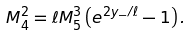Convert formula to latex. <formula><loc_0><loc_0><loc_500><loc_500>M _ { 4 } ^ { 2 } = \ell M _ { 5 } ^ { 3 } \left ( e ^ { 2 y _ { - } / \ell } - 1 \right ) .</formula> 